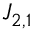<formula> <loc_0><loc_0><loc_500><loc_500>J _ { 2 , 1 }</formula> 